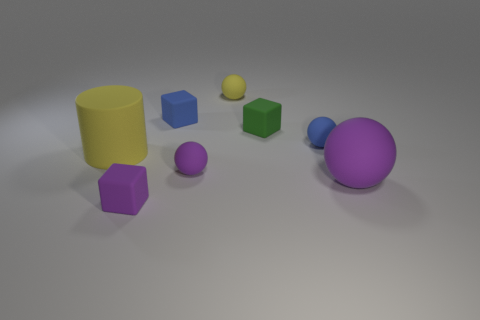Is there anything else that is the same shape as the big yellow rubber thing?
Your answer should be compact. No. Is the material of the purple thing to the right of the green cube the same as the object behind the tiny blue cube?
Provide a succinct answer. Yes. What is the material of the tiny purple cube?
Offer a terse response. Rubber. How many purple blocks are made of the same material as the large purple object?
Ensure brevity in your answer.  1. How many matte things are large cylinders or green objects?
Ensure brevity in your answer.  2. Do the yellow rubber thing right of the matte cylinder and the large object left of the blue ball have the same shape?
Offer a very short reply. No. There is a tiny rubber block that is to the left of the tiny green rubber cube and behind the purple matte cube; what color is it?
Ensure brevity in your answer.  Blue. There is a blue thing that is on the left side of the green rubber cube; does it have the same size as the block in front of the large yellow object?
Offer a very short reply. Yes. How many other matte balls are the same color as the big ball?
Your response must be concise. 1. What number of big objects are either red objects or things?
Offer a very short reply. 2. 